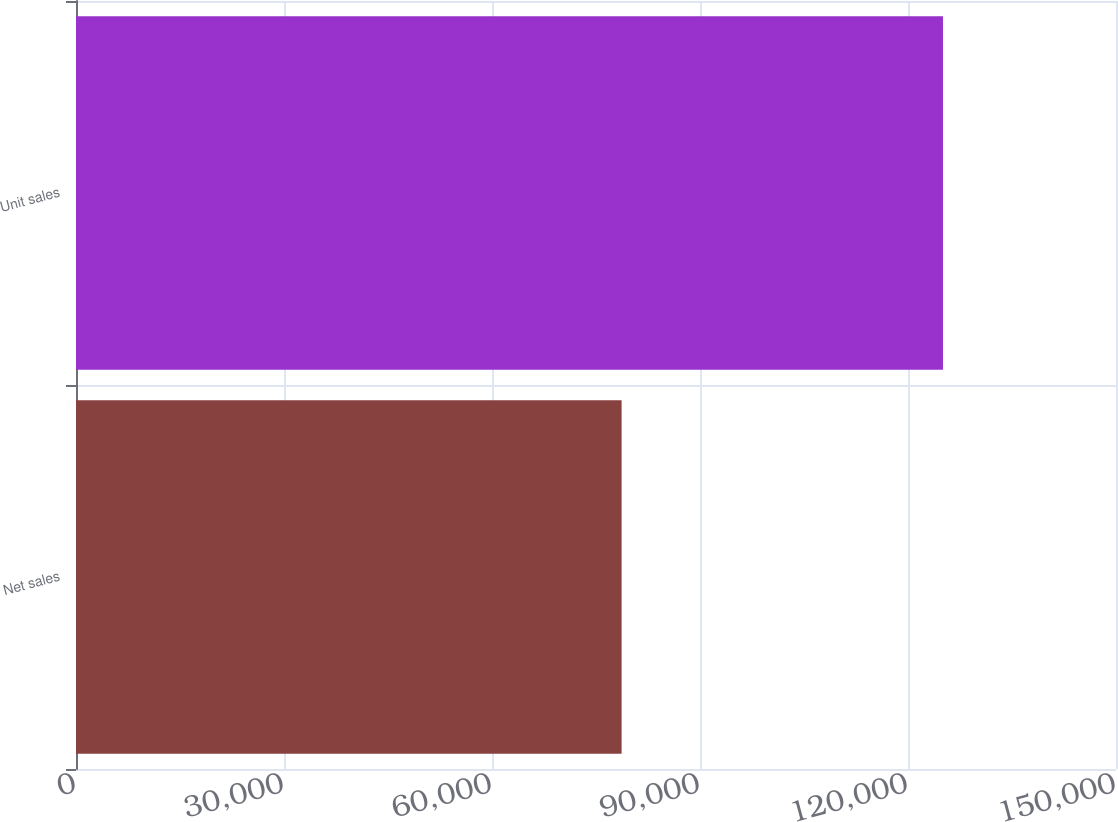Convert chart. <chart><loc_0><loc_0><loc_500><loc_500><bar_chart><fcel>Net sales<fcel>Unit sales<nl><fcel>78692<fcel>125046<nl></chart> 